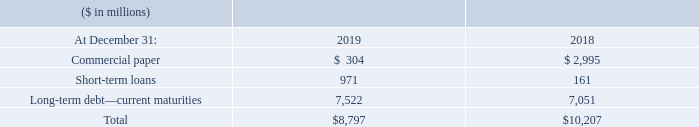Short-Term Debt
The weighted-average interest rate for commercial paper at December 31, 2019 and 2018 was 1.6 percent and 2.5 percent, respectively. The weighted-average interest rates for short-term loans were 6.1 percent and 4.3 percent at December 31, 2019 and 2018, respectively.
What was the weighted average interest rate for commercial paper at December 31, 2019? 1.6 percent. What was the commercial paper in 2018?
Answer scale should be: million. $ 2,995. What was the increase / (decrease) in the short term loan from 2018 to 2019?
Answer scale should be: million. 971 - 161
Answer: 810. What was the average Long-term debt—current maturities?
Answer scale should be: million. (7,522 + 7,051) / 2
Answer: 7286.5. What was the percentage increase / (decrease) in total short term debt?
Answer scale should be: percent. 8,797 / 10,207 - 1
Answer: -13.81. What was the weighted average interest rate for short-term loans at December 31, 2019? 6.1 percent. 